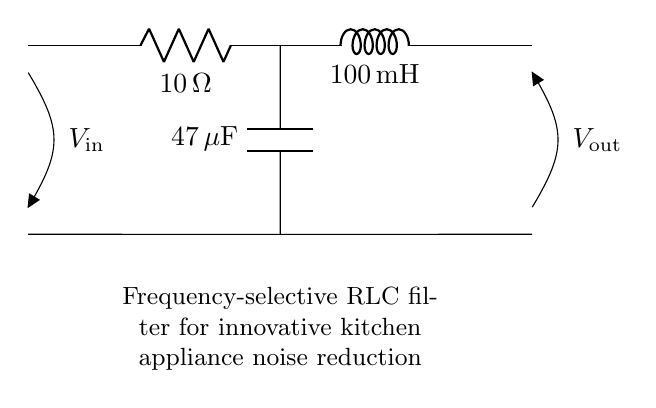What are the components in this circuit? The circuit diagram displays three main components: a resistor, an inductor, and a capacitor, which are connected in series.
Answer: Resistor, Inductor, Capacitor What is the resistance value of the resistor? The resistance value is indicated directly next to the resistor in the diagram, which shows it as ten ohms.
Answer: Ten ohms What is the inductance of the inductor? The inductance is provided next to the inductor in the circuit diagram, where it states one hundred milliHenry.
Answer: One hundred milliHenry What is the capacitance of the capacitor? The capacitance value is specified beside the capacitor in the diagram, which shows it as forty-seven microFarads.
Answer: Forty-seven microFarads What is the purpose of this RLC filter? The filter is designed for frequency-selective noise reduction in innovative kitchen appliances, as indicated in the caption.
Answer: Noise reduction How does the combination of RLC affect the frequency response? The series combination of the resistor, inductor, and capacitor forms a resonant circuit that can selectively allow certain frequencies to pass while attenuating others, affecting the overall frequency response of the circuit.
Answer: It allows selective frequencies to pass What type of filter is represented by this RLC circuit? Given the values and arrangement of the components, it functions as a band-pass filter, which is primarily used in applications to focus on a defined frequency range.
Answer: Band-pass filter 